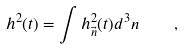Convert formula to latex. <formula><loc_0><loc_0><loc_500><loc_500>h ^ { 2 } ( t ) = \int h ^ { 2 } _ { \vec { n } } ( t ) d ^ { 3 } n \quad ,</formula> 